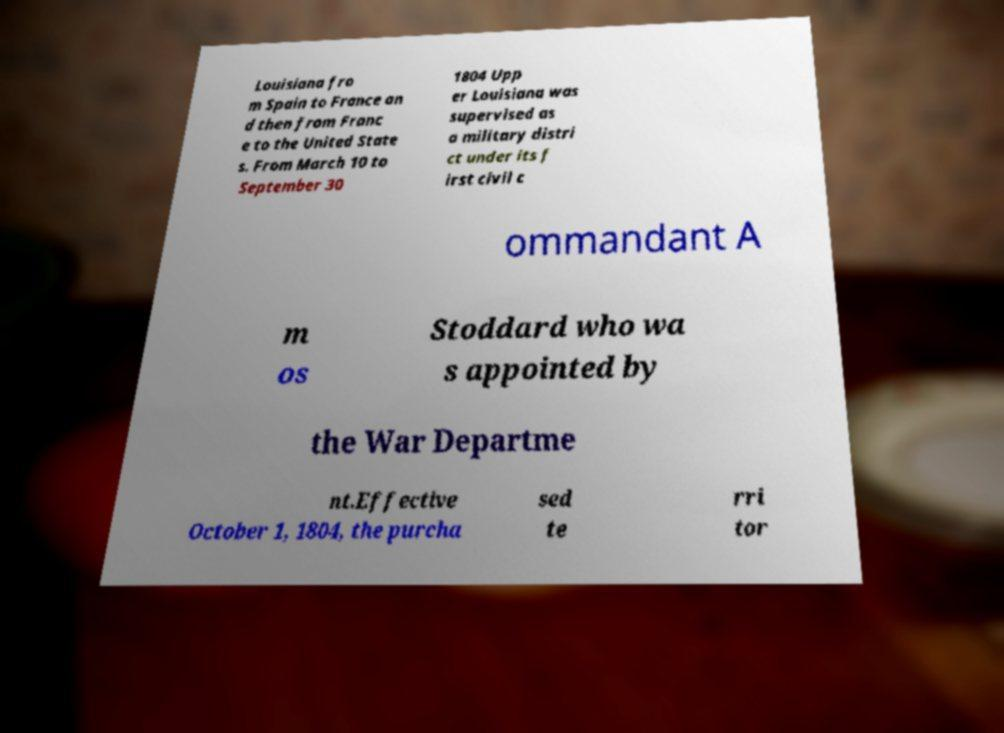Could you extract and type out the text from this image? Louisiana fro m Spain to France an d then from Franc e to the United State s. From March 10 to September 30 1804 Upp er Louisiana was supervised as a military distri ct under its f irst civil c ommandant A m os Stoddard who wa s appointed by the War Departme nt.Effective October 1, 1804, the purcha sed te rri tor 